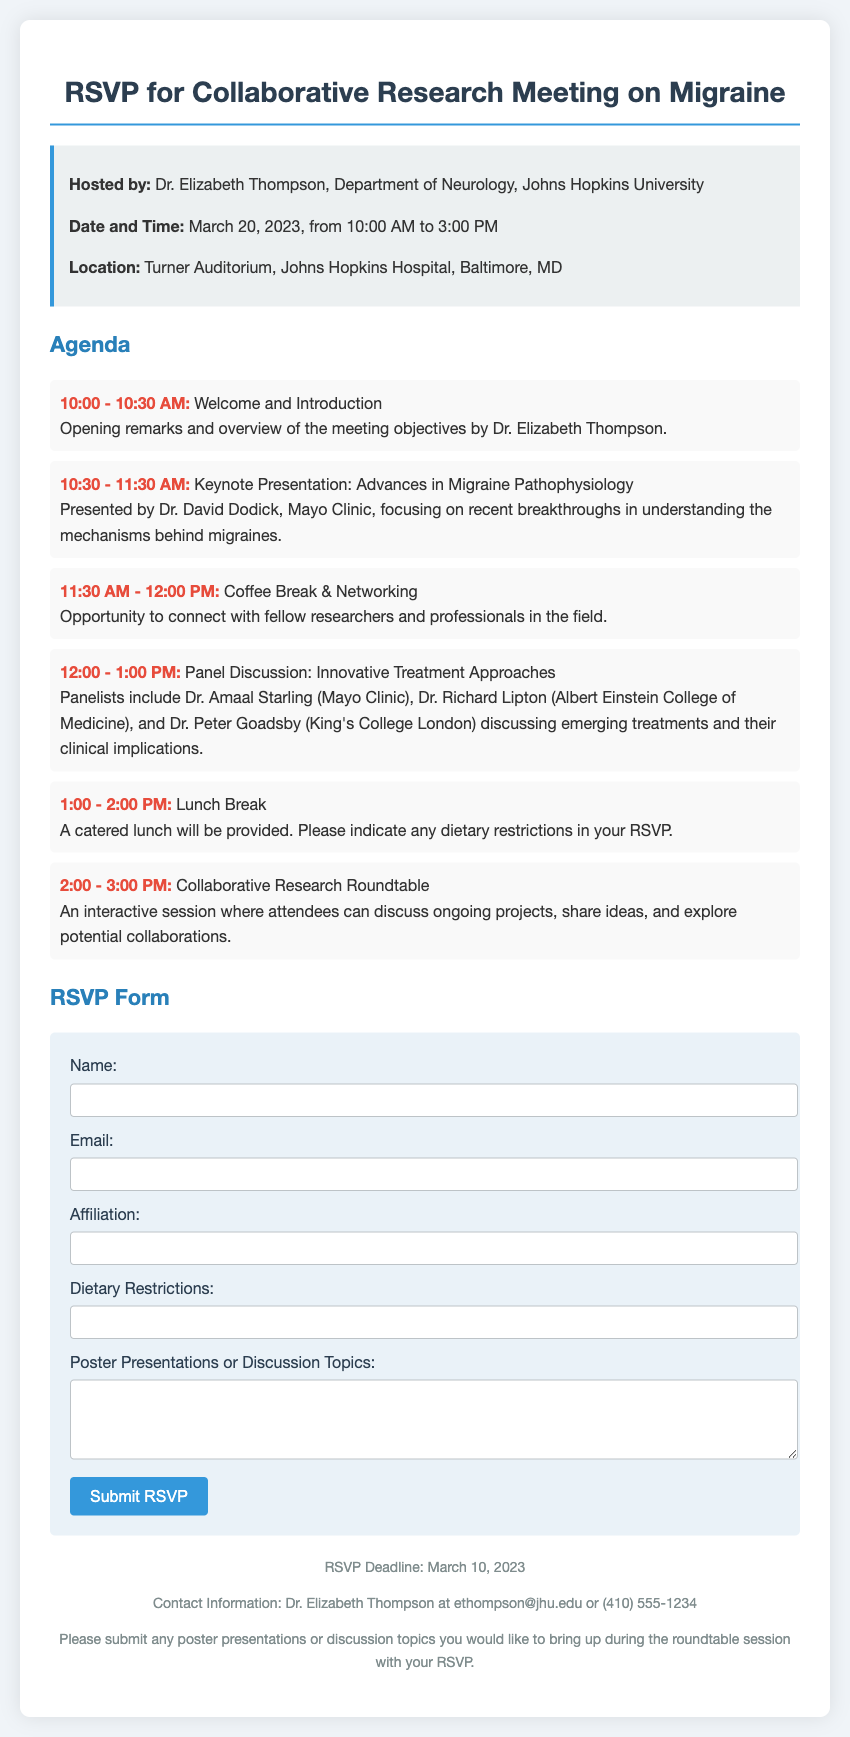What is the date of the meeting? The date of the meeting is explicitly stated in the document under "Date and Time."
Answer: March 20, 2023 Who is the keynote speaker? The keynote speaker's name is mentioned in the agenda section of the document.
Answer: Dr. David Dodick What time does the lunch break start? The lunch break's start time is provided in the agenda section of the document.
Answer: 1:00 PM What is the RSVP deadline? The RSVP deadline is mentioned in the footer section of the document.
Answer: March 10, 2023 What is the location of the meeting? The location is specified in the information section of the document.
Answer: Turner Auditorium, Johns Hopkins Hospital, Baltimore, MD How long is the panel discussion scheduled for? The duration of the panel discussion is specified in the agenda section of the document.
Answer: 1 hour Who should be contacted for more information? The contact information for inquiries is provided in the footer section of the document.
Answer: Dr. Elizabeth Thompson What dietary considerations should attendees provide? Attendees are asked to indicate dietary restrictions in the RSVP form.
Answer: Dietary Restrictions 